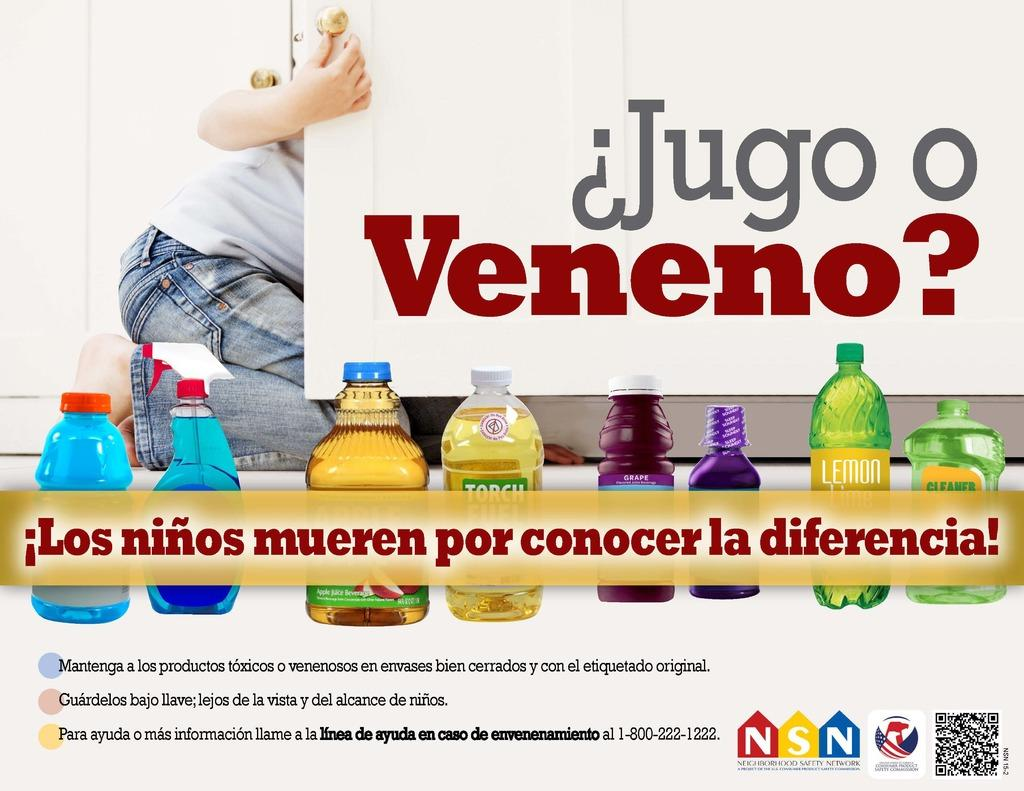<image>
Render a clear and concise summary of the photo. A person in jeans is behind a cabinet that says Jugo o Veneno. 